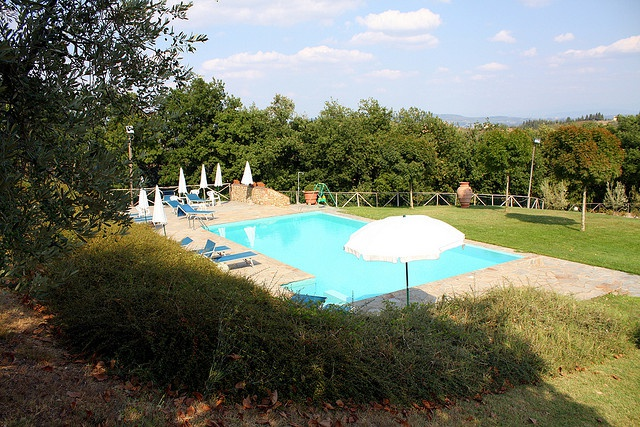Describe the objects in this image and their specific colors. I can see umbrella in black, white, cyan, and darkgray tones, bench in black, beige, lightblue, tan, and teal tones, chair in black, lightblue, beige, teal, and darkgray tones, umbrella in black, white, darkgray, and tan tones, and chair in black, ivory, lightblue, gray, and darkgray tones in this image. 